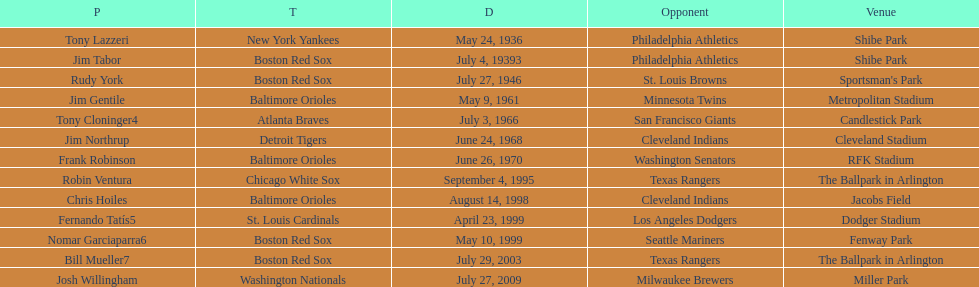Parse the full table. {'header': ['P', 'T', 'D', 'Opponent', 'Venue'], 'rows': [['Tony Lazzeri', 'New York Yankees', 'May 24, 1936', 'Philadelphia Athletics', 'Shibe Park'], ['Jim Tabor', 'Boston Red Sox', 'July 4, 19393', 'Philadelphia Athletics', 'Shibe Park'], ['Rudy York', 'Boston Red Sox', 'July 27, 1946', 'St. Louis Browns', "Sportsman's Park"], ['Jim Gentile', 'Baltimore Orioles', 'May 9, 1961', 'Minnesota Twins', 'Metropolitan Stadium'], ['Tony Cloninger4', 'Atlanta Braves', 'July 3, 1966', 'San Francisco Giants', 'Candlestick Park'], ['Jim Northrup', 'Detroit Tigers', 'June 24, 1968', 'Cleveland Indians', 'Cleveland Stadium'], ['Frank Robinson', 'Baltimore Orioles', 'June 26, 1970', 'Washington Senators', 'RFK Stadium'], ['Robin Ventura', 'Chicago White Sox', 'September 4, 1995', 'Texas Rangers', 'The Ballpark in Arlington'], ['Chris Hoiles', 'Baltimore Orioles', 'August 14, 1998', 'Cleveland Indians', 'Jacobs Field'], ['Fernando Tatís5', 'St. Louis Cardinals', 'April 23, 1999', 'Los Angeles Dodgers', 'Dodger Stadium'], ['Nomar Garciaparra6', 'Boston Red Sox', 'May 10, 1999', 'Seattle Mariners', 'Fenway Park'], ['Bill Mueller7', 'Boston Red Sox', 'July 29, 2003', 'Texas Rangers', 'The Ballpark in Arlington'], ['Josh Willingham', 'Washington Nationals', 'July 27, 2009', 'Milwaukee Brewers', 'Miller Park']]} What was the name of the last person to accomplish this up to date? Josh Willingham. 